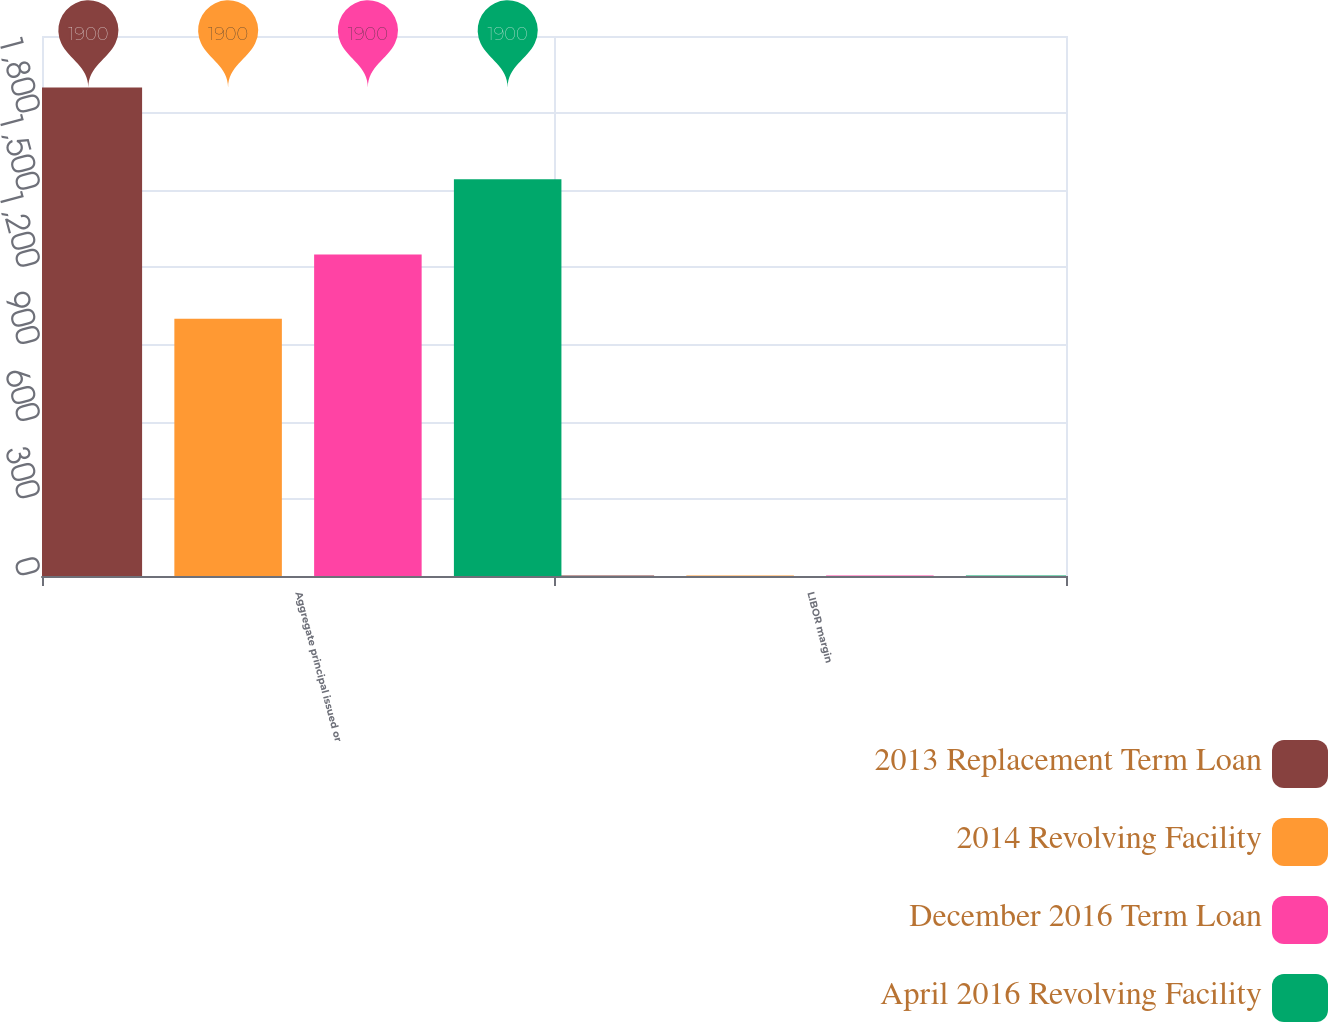Convert chart. <chart><loc_0><loc_0><loc_500><loc_500><stacked_bar_chart><ecel><fcel>Aggregate principal issued or<fcel>LIBOR margin<nl><fcel>2013 Replacement Term Loan<fcel>1900<fcel>1.75<nl><fcel>2014 Revolving Facility<fcel>1000<fcel>2<nl><fcel>December 2016 Term Loan<fcel>1250<fcel>2<nl><fcel>April 2016 Revolving Facility<fcel>1543<fcel>2<nl></chart> 